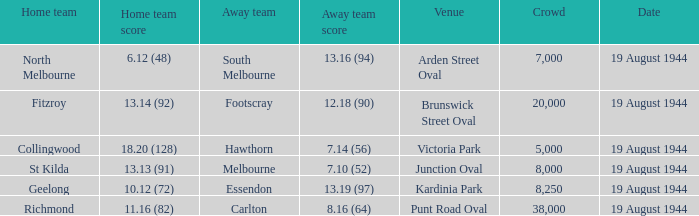What is Fitzroy's Home team Crowd? 20000.0. 